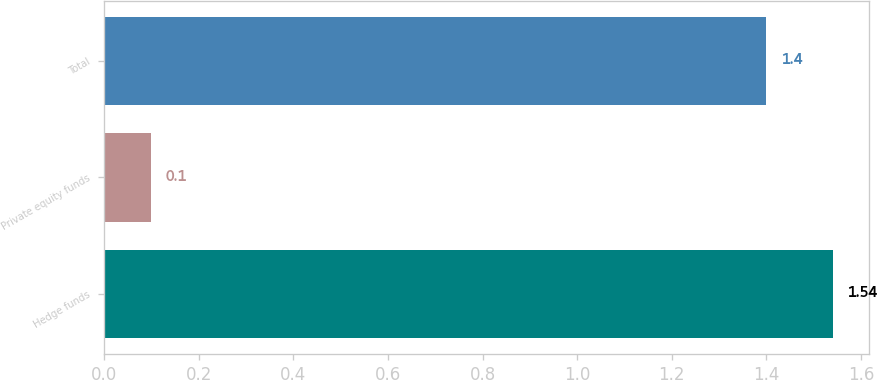Convert chart. <chart><loc_0><loc_0><loc_500><loc_500><bar_chart><fcel>Hedge funds<fcel>Private equity funds<fcel>Total<nl><fcel>1.54<fcel>0.1<fcel>1.4<nl></chart> 